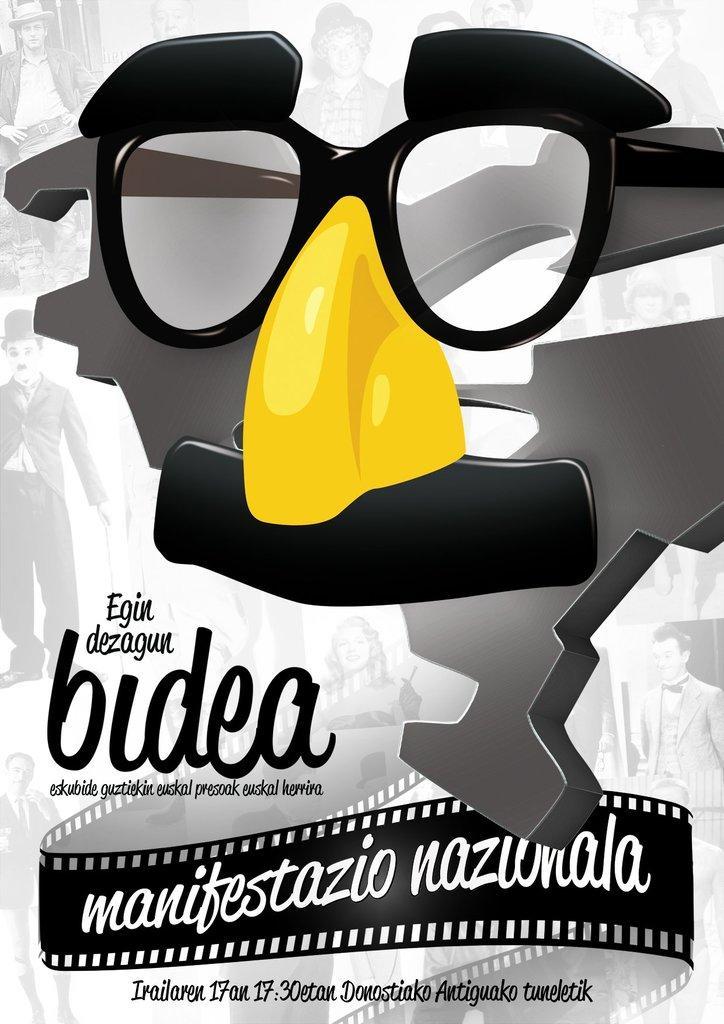Can you describe this image briefly? In this picture I can see a mask like thing in front and I see something is written on the bottom side of this picture. I can also see few pictures of people. 